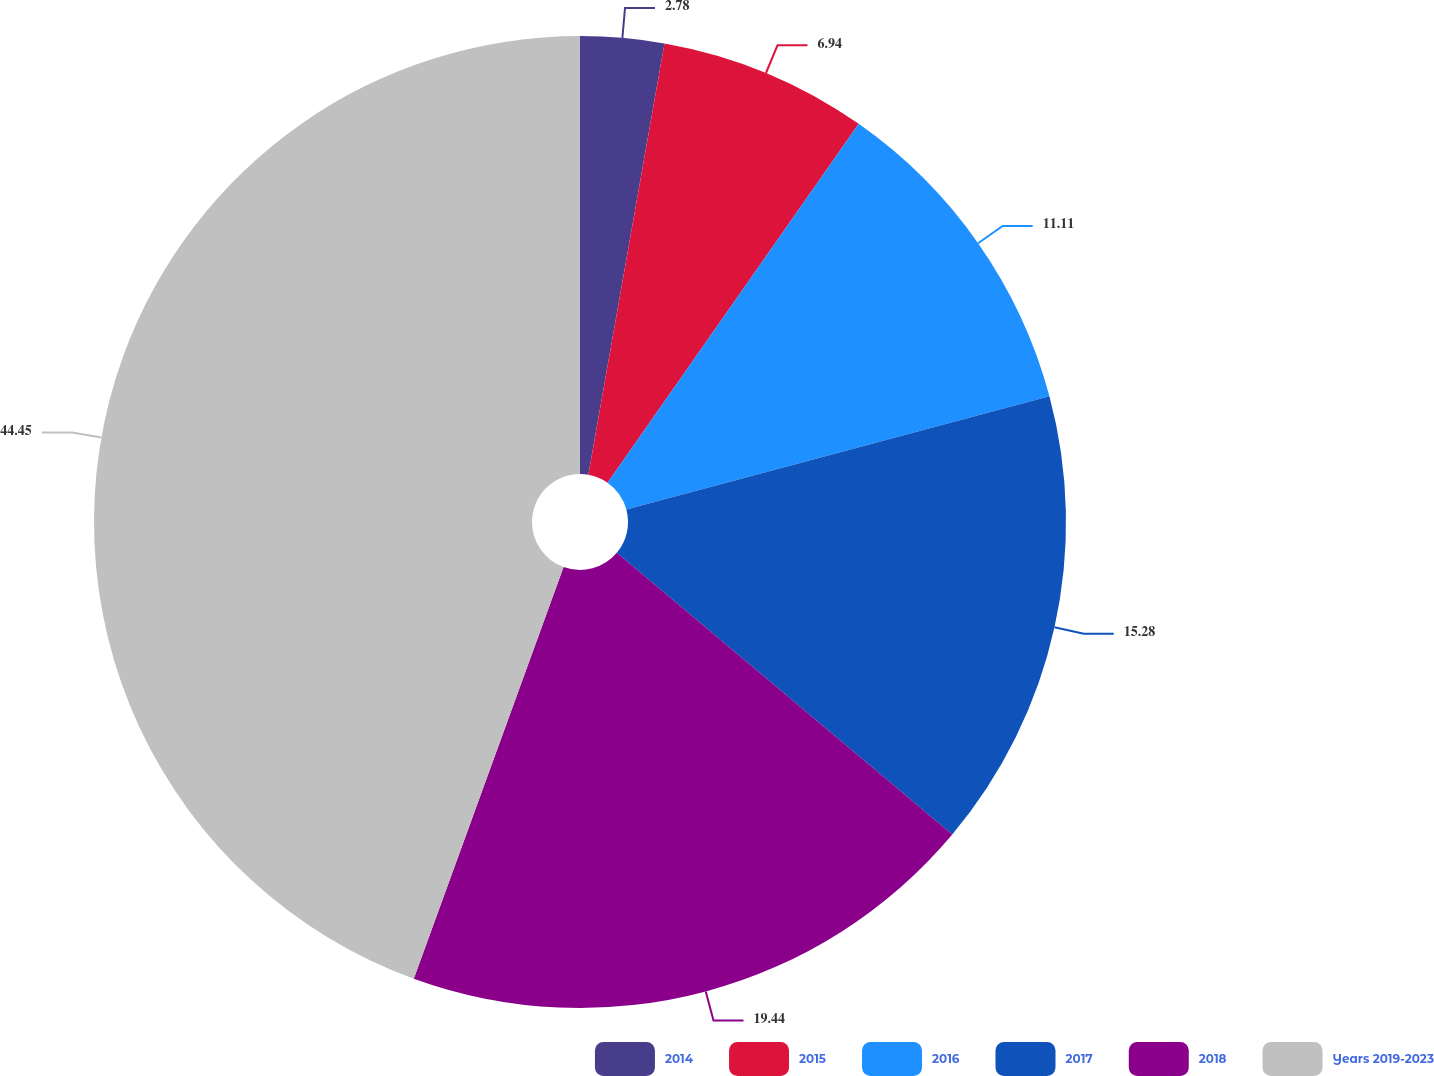Convert chart. <chart><loc_0><loc_0><loc_500><loc_500><pie_chart><fcel>2014<fcel>2015<fcel>2016<fcel>2017<fcel>2018<fcel>Years 2019-2023<nl><fcel>2.78%<fcel>6.94%<fcel>11.11%<fcel>15.28%<fcel>19.44%<fcel>44.44%<nl></chart> 